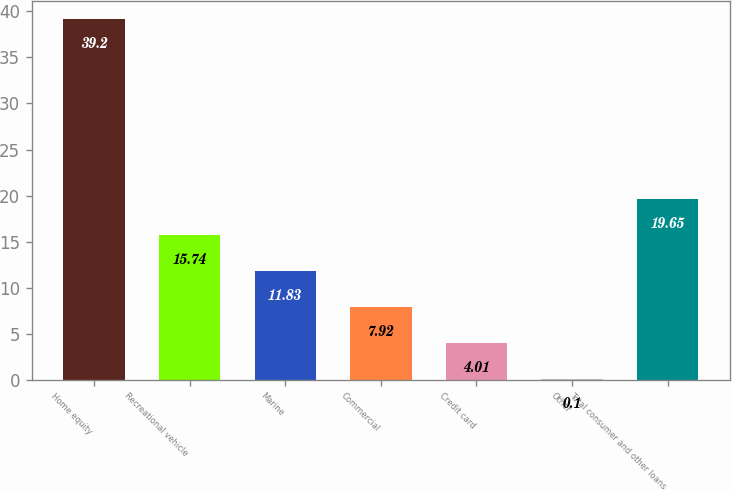Convert chart. <chart><loc_0><loc_0><loc_500><loc_500><bar_chart><fcel>Home equity<fcel>Recreational vehicle<fcel>Marine<fcel>Commercial<fcel>Credit card<fcel>Other<fcel>Total consumer and other loans<nl><fcel>39.2<fcel>15.74<fcel>11.83<fcel>7.92<fcel>4.01<fcel>0.1<fcel>19.65<nl></chart> 